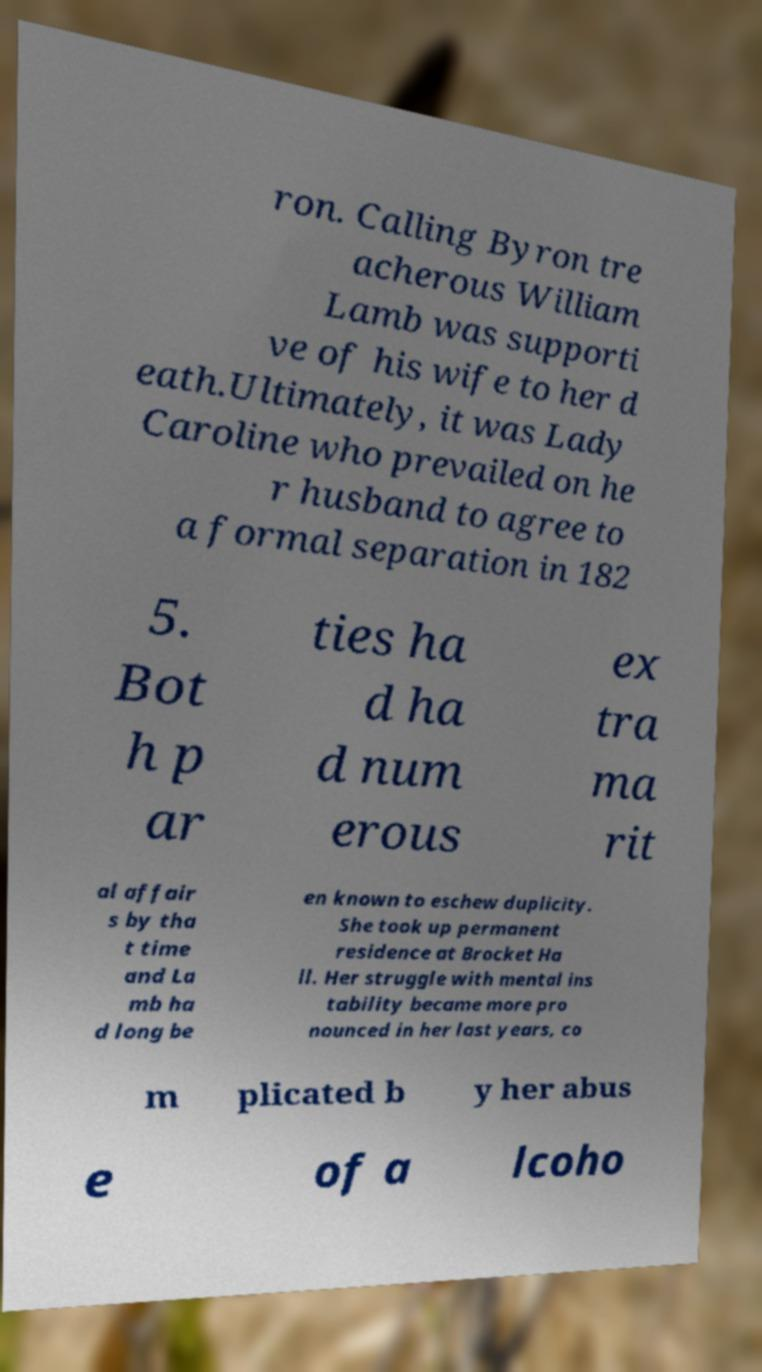Can you read and provide the text displayed in the image?This photo seems to have some interesting text. Can you extract and type it out for me? ron. Calling Byron tre acherous William Lamb was supporti ve of his wife to her d eath.Ultimately, it was Lady Caroline who prevailed on he r husband to agree to a formal separation in 182 5. Bot h p ar ties ha d ha d num erous ex tra ma rit al affair s by tha t time and La mb ha d long be en known to eschew duplicity. She took up permanent residence at Brocket Ha ll. Her struggle with mental ins tability became more pro nounced in her last years, co m plicated b y her abus e of a lcoho 